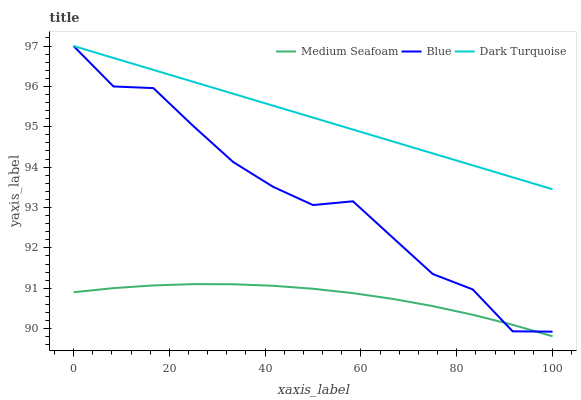Does Medium Seafoam have the minimum area under the curve?
Answer yes or no. Yes. Does Dark Turquoise have the maximum area under the curve?
Answer yes or no. Yes. Does Dark Turquoise have the minimum area under the curve?
Answer yes or no. No. Does Medium Seafoam have the maximum area under the curve?
Answer yes or no. No. Is Dark Turquoise the smoothest?
Answer yes or no. Yes. Is Blue the roughest?
Answer yes or no. Yes. Is Medium Seafoam the smoothest?
Answer yes or no. No. Is Medium Seafoam the roughest?
Answer yes or no. No. Does Medium Seafoam have the lowest value?
Answer yes or no. Yes. Does Dark Turquoise have the lowest value?
Answer yes or no. No. Does Dark Turquoise have the highest value?
Answer yes or no. Yes. Does Medium Seafoam have the highest value?
Answer yes or no. No. Is Medium Seafoam less than Dark Turquoise?
Answer yes or no. Yes. Is Dark Turquoise greater than Medium Seafoam?
Answer yes or no. Yes. Does Blue intersect Medium Seafoam?
Answer yes or no. Yes. Is Blue less than Medium Seafoam?
Answer yes or no. No. Is Blue greater than Medium Seafoam?
Answer yes or no. No. Does Medium Seafoam intersect Dark Turquoise?
Answer yes or no. No. 